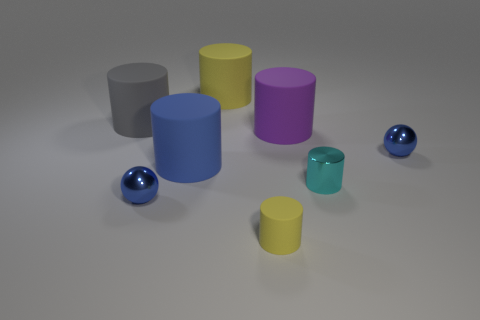Is there anything else that has the same size as the blue matte thing?
Offer a very short reply. Yes. Is the tiny metal cylinder the same color as the small rubber cylinder?
Offer a terse response. No. What is the color of the large matte cylinder in front of the small object that is to the right of the tiny cyan cylinder?
Give a very brief answer. Blue. How many big objects are purple rubber cylinders or rubber things?
Give a very brief answer. 4. There is a rubber cylinder that is both behind the purple matte thing and in front of the large yellow rubber thing; what color is it?
Offer a very short reply. Gray. Are the gray object and the big blue object made of the same material?
Keep it short and to the point. Yes. What shape is the large yellow object?
Offer a very short reply. Cylinder. How many rubber cylinders are to the right of the yellow cylinder behind the large blue cylinder that is to the right of the large gray rubber object?
Your response must be concise. 2. There is a metallic thing that is the same shape as the small matte thing; what is its color?
Your answer should be very brief. Cyan. The small blue metal thing that is in front of the blue metallic sphere on the right side of the yellow rubber cylinder behind the purple rubber cylinder is what shape?
Your answer should be compact. Sphere. 